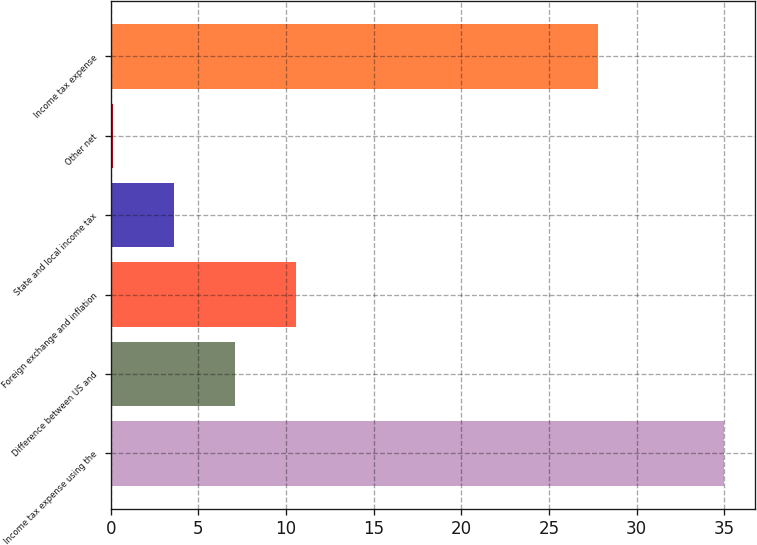Convert chart to OTSL. <chart><loc_0><loc_0><loc_500><loc_500><bar_chart><fcel>Income tax expense using the<fcel>Difference between US and<fcel>Foreign exchange and inflation<fcel>State and local income tax<fcel>Other net<fcel>Income tax expense<nl><fcel>35<fcel>7.08<fcel>10.57<fcel>3.59<fcel>0.1<fcel>27.8<nl></chart> 